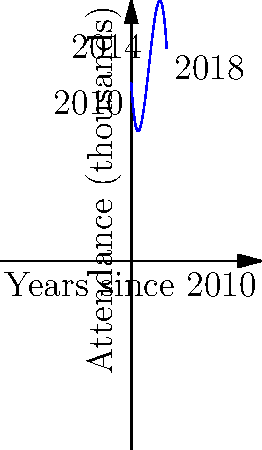As a rare film collector, you've been tracking the attendance of the Melbourne International Film Festival over the years. The graph shows the attendance trend from 2010 to 2018, modeled by the polynomial function $f(x) = -0.5x^3 + 6x^2 - 15x + 40$, where $x$ represents the number of years since 2010 and $f(x)$ represents attendance in thousands. Based on this trend, what would be the expected attendance (to the nearest thousand) for the festival in 2020? To solve this problem, we need to follow these steps:

1) First, we need to determine what value of $x$ corresponds to the year 2020:
   2020 is 10 years after 2010, so $x = 10$.

2) Now, we need to evaluate the function $f(x)$ at $x = 10$:
   
   $f(10) = -0.5(10)^3 + 6(10)^2 - 15(10) + 40$

3) Let's calculate this step by step:
   
   $f(10) = -0.5(1000) + 6(100) - 15(10) + 40$
   $f(10) = -500 + 600 - 150 + 40$
   $f(10) = -10$

4) The result is -10, but remember that $f(x)$ represents attendance in thousands.
   A negative attendance doesn't make sense in this context.

5) Given that the polynomial is decreasing rapidly after 2018, and real-world attendance can't be negative, we can interpret this result as the festival potentially being cancelled or having negligible attendance.

6) Rounding to the nearest thousand as requested in the question, the expected attendance would be 0 thousand.
Answer: 0 thousand 